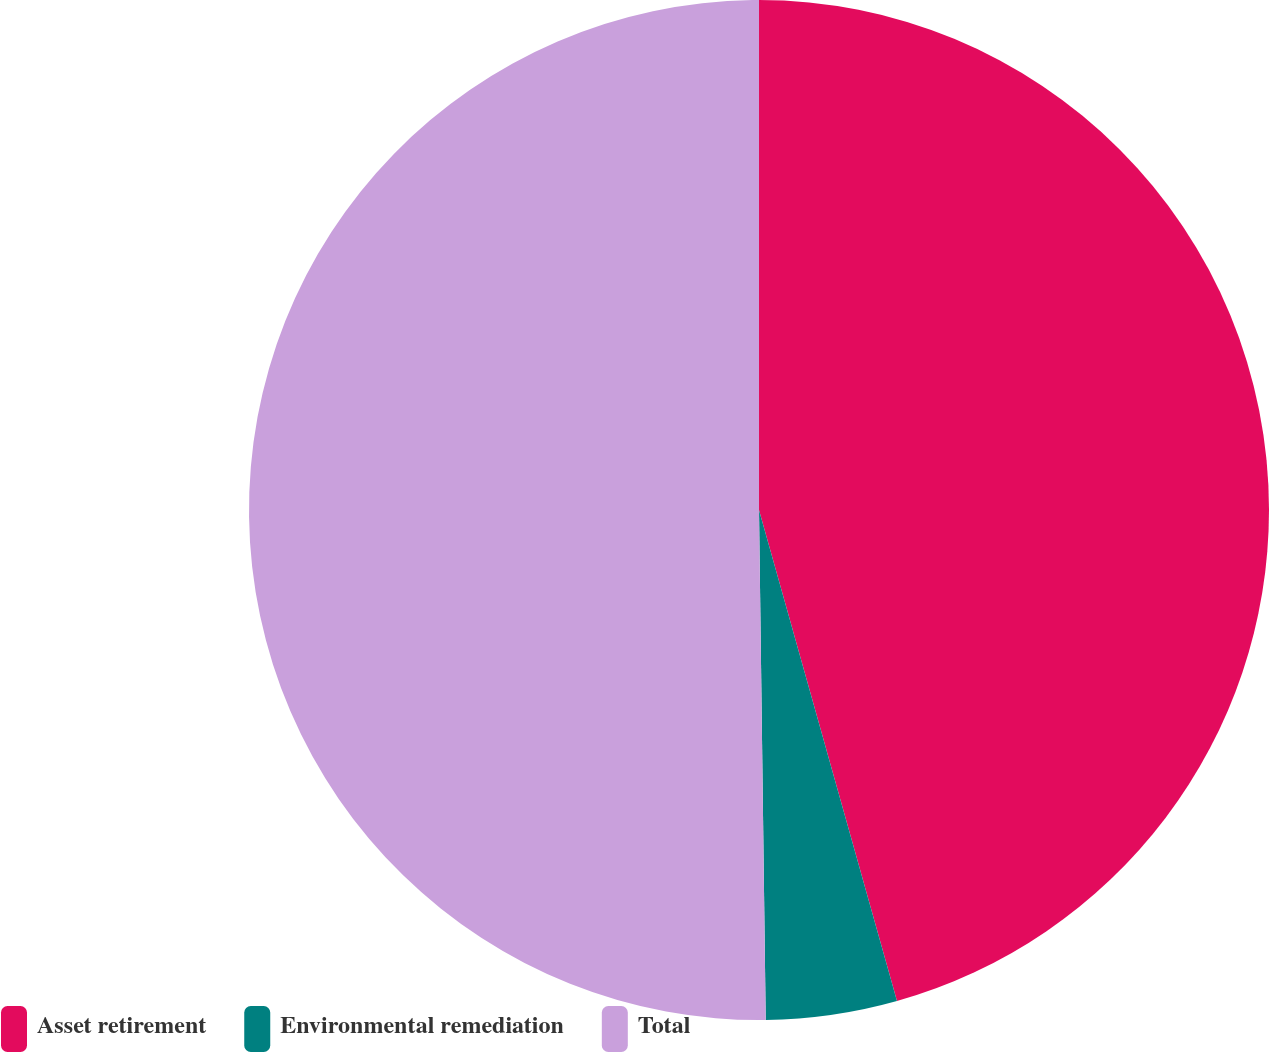<chart> <loc_0><loc_0><loc_500><loc_500><pie_chart><fcel>Asset retirement<fcel>Environmental remediation<fcel>Total<nl><fcel>45.64%<fcel>4.15%<fcel>50.21%<nl></chart> 